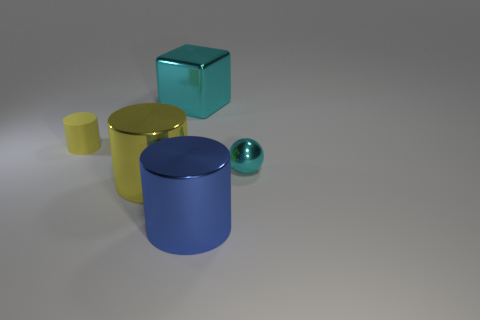Is there any other thing that is the same shape as the large cyan thing?
Keep it short and to the point. No. Do the shiny ball and the metallic cylinder on the right side of the metallic cube have the same size?
Ensure brevity in your answer.  No. Do the yellow cylinder in front of the sphere and the cyan object that is behind the small cyan thing have the same material?
Offer a very short reply. Yes. Are there the same number of large yellow metal cylinders that are behind the large cyan shiny object and cyan balls to the right of the cyan metallic sphere?
Your response must be concise. Yes. What number of other cylinders have the same color as the tiny cylinder?
Give a very brief answer. 1. How many matte objects are yellow cylinders or big cubes?
Provide a short and direct response. 1. Does the large thing behind the tiny yellow object have the same shape as the tiny object that is on the right side of the blue cylinder?
Offer a very short reply. No. There is a large blue metallic thing; how many tiny things are to the left of it?
Make the answer very short. 1. Is there a cyan object that has the same material as the tiny yellow cylinder?
Offer a very short reply. No. There is a thing that is the same size as the cyan metal ball; what material is it?
Ensure brevity in your answer.  Rubber. 